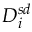<formula> <loc_0><loc_0><loc_500><loc_500>D _ { i } ^ { s d }</formula> 